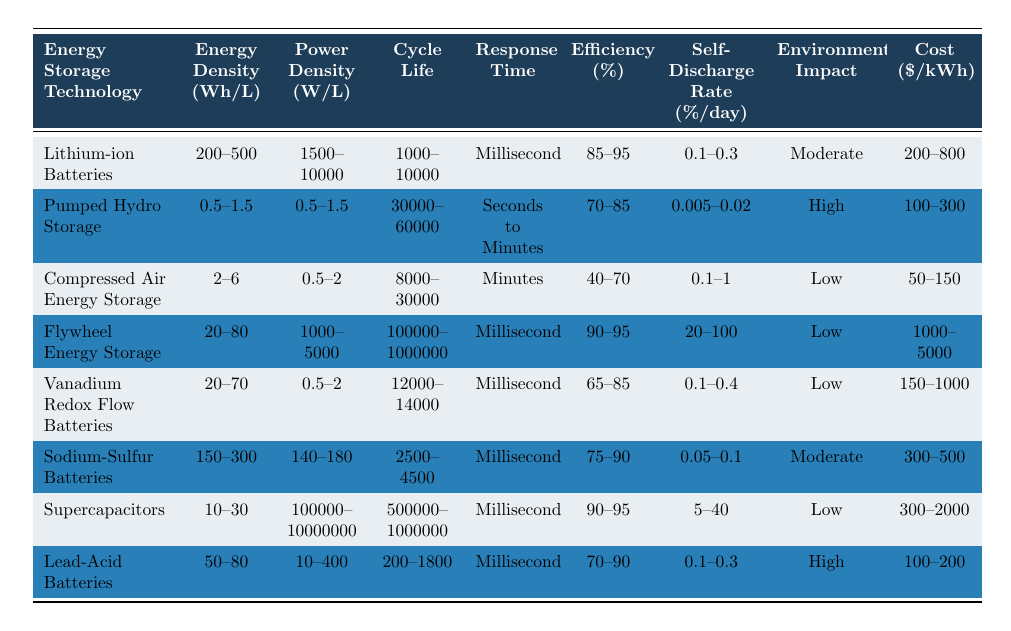What is the energy density range of Lithium-ion Batteries? The table lists the energy density of Lithium-ion Batteries as ranging from 200 to 500 Wh/L.
Answer: 200-500 Wh/L Which energy storage technology has the highest self-discharge rate? Looking at the self-discharge rates in the table, Flywheel Energy Storage has the highest self-discharge rate ranging from 20 to 100% per day.
Answer: Flywheel Energy Storage What is the average cost of Sodium-Sulfur Batteries? The cost range for Sodium-Sulfur Batteries is from 300 to 500 $/kWh. To find the average, we calculate (300 + 500) / 2 = 400.
Answer: 400 $/kWh Is the response time for Compressed Air Energy Storage faster than that of Pumped Hydro Storage? The response time for Compressed Air Energy Storage is listed as "Minutes," whereas Pumped Hydro Storage has a response time of "Seconds to Minutes." Since Minutes can be slower than Seconds, the answer is no.
Answer: No Which storage technology has the longest cycle life? The table shows that Pumped Hydro Storage has the longest cycle life range of 30,000 to 60,000 cycles.
Answer: Pumped Hydro Storage What is the difference in power density between Supercapacitors and Lead-Acid Batteries? The power density for Supercapacitors is 10,000,000 W/L (10 million) and for Lead-Acid Batteries, it is 400 W/L. The difference is calculated as 10,000,000 - 400 = 9,999,600 W/L.
Answer: 9,999,600 W/L How does the environmental impact of Vanadium Redox Flow Batteries compare to other technologies? Vanadium Redox Flow Batteries have a "Low" environmental impact, which is better compared to Pumped Hydro Storage and Lead-Acid Batteries that are categorized as "High."
Answer: Low Which technology offers the best efficiency percentage? Checking the efficiency percentages, both Lithium-ion Batteries and Supercapacitors have the highest efficiency rates ranging from 90% to 95%.
Answer: Lithium-ion Batteries and Supercapacitors What is the combined self-discharge rate of Compressed Air Energy Storage and Lead-Acid Batteries? The self-discharge rates are 0.1 to 1%/day for Compressed Air Energy Storage and 0.1 to 0.3%/day for Lead-Acid Batteries. The combined range would be from (0.1 + 0.1) to (1 + 0.3), which is 0.2%/day to 1.3%/day.
Answer: 0.2%/day to 1.3%/day Is there a technology with both a high energy density and a low cost? By examining the table, Lithium-ion Batteries have high energy density (200-500 Wh/L) and moderate cost (200-800 $/kWh), while Compressed Air Energy Storage has low cost (50-150 $/kWh) but low energy density (2-6 Wh/L). Thus, there is no such technology.
Answer: No 